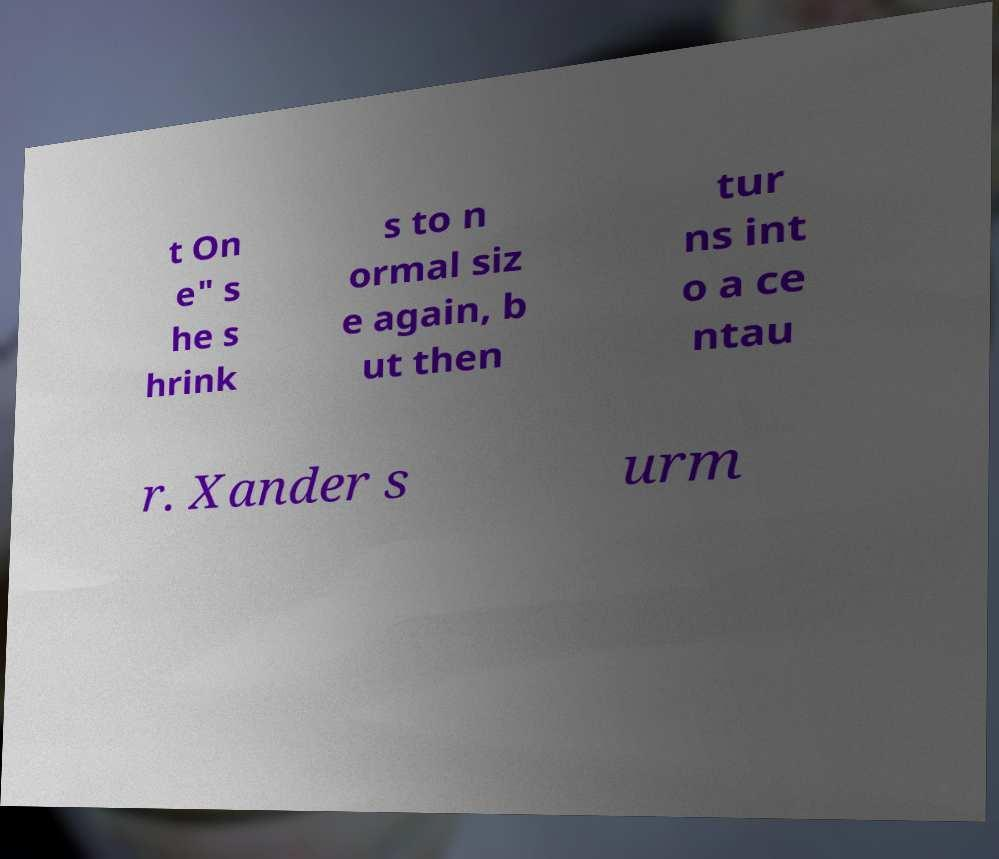What messages or text are displayed in this image? I need them in a readable, typed format. t On e" s he s hrink s to n ormal siz e again, b ut then tur ns int o a ce ntau r. Xander s urm 